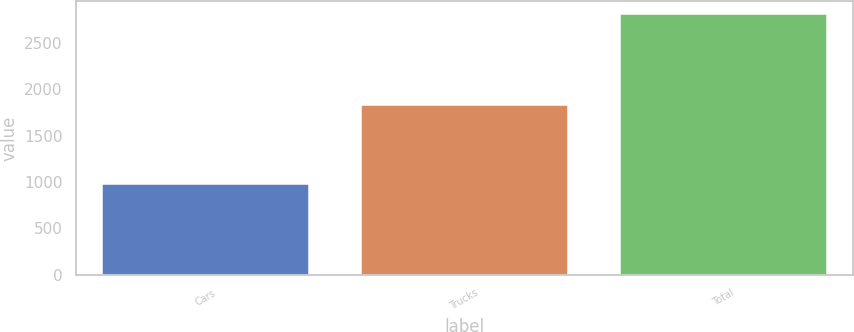Convert chart to OTSL. <chart><loc_0><loc_0><loc_500><loc_500><bar_chart><fcel>Cars<fcel>Trucks<fcel>Total<nl><fcel>977<fcel>1832<fcel>2809<nl></chart> 